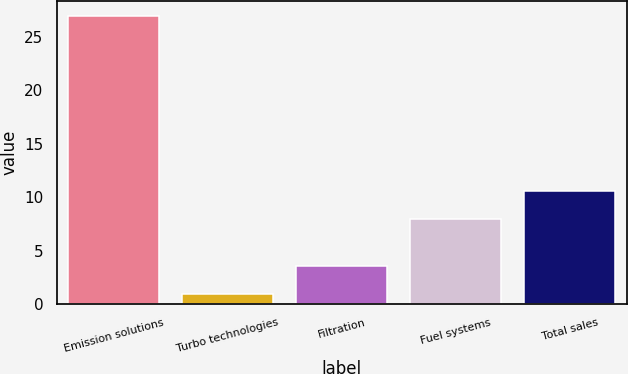Convert chart. <chart><loc_0><loc_0><loc_500><loc_500><bar_chart><fcel>Emission solutions<fcel>Turbo technologies<fcel>Filtration<fcel>Fuel systems<fcel>Total sales<nl><fcel>27<fcel>1<fcel>3.6<fcel>8<fcel>10.6<nl></chart> 